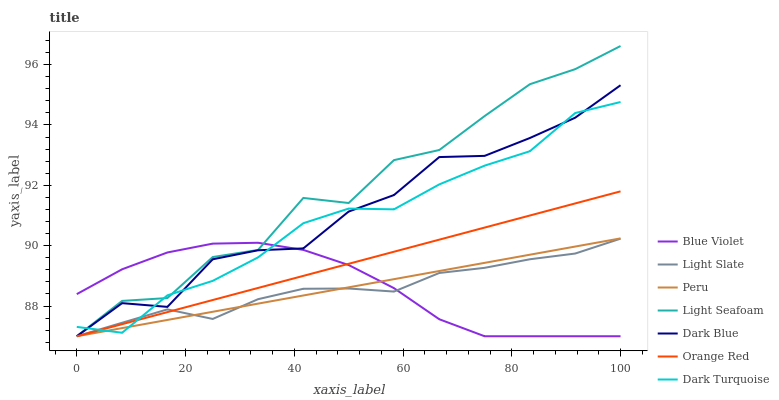Does Light Slate have the minimum area under the curve?
Answer yes or no. Yes. Does Light Seafoam have the maximum area under the curve?
Answer yes or no. Yes. Does Dark Turquoise have the minimum area under the curve?
Answer yes or no. No. Does Dark Turquoise have the maximum area under the curve?
Answer yes or no. No. Is Peru the smoothest?
Answer yes or no. Yes. Is Light Seafoam the roughest?
Answer yes or no. Yes. Is Dark Turquoise the smoothest?
Answer yes or no. No. Is Dark Turquoise the roughest?
Answer yes or no. No. Does Light Slate have the lowest value?
Answer yes or no. Yes. Does Dark Turquoise have the lowest value?
Answer yes or no. No. Does Light Seafoam have the highest value?
Answer yes or no. Yes. Does Dark Turquoise have the highest value?
Answer yes or no. No. Does Orange Red intersect Light Slate?
Answer yes or no. Yes. Is Orange Red less than Light Slate?
Answer yes or no. No. Is Orange Red greater than Light Slate?
Answer yes or no. No. 